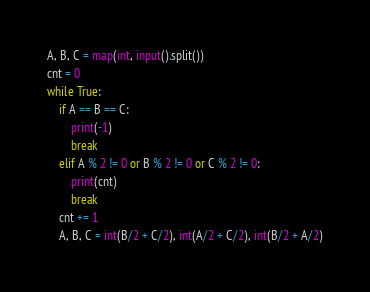Convert code to text. <code><loc_0><loc_0><loc_500><loc_500><_Python_>A, B, C = map(int, input().split())
cnt = 0
while True:
    if A == B == C:
        print(-1)
        break
    elif A % 2 != 0 or B % 2 != 0 or C % 2 != 0:
        print(cnt)
        break
    cnt += 1
    A, B, C = int(B/2 + C/2), int(A/2 + C/2), int(B/2 + A/2)
</code> 